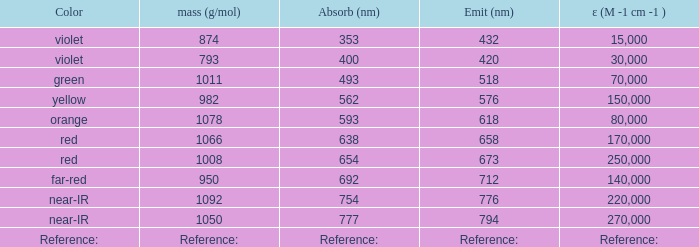Identify the emission in nanometers for a substance with a molar mass of 1078 g/mol. 618.0. 